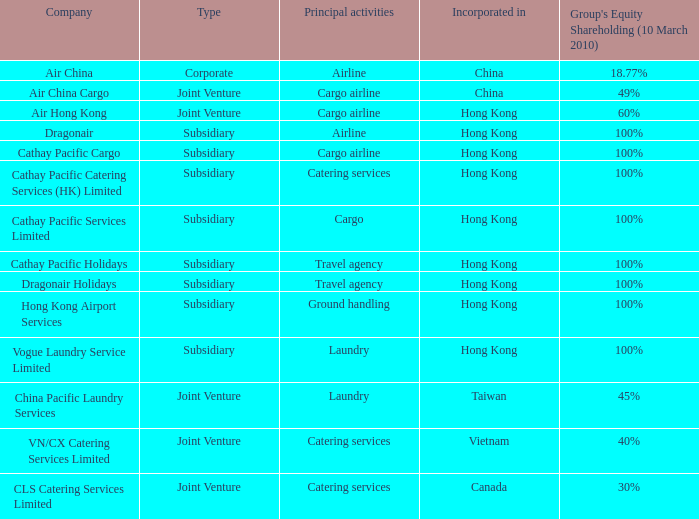What is the Group's equity share percentage for Company VN/CX catering services limited? 40%. 